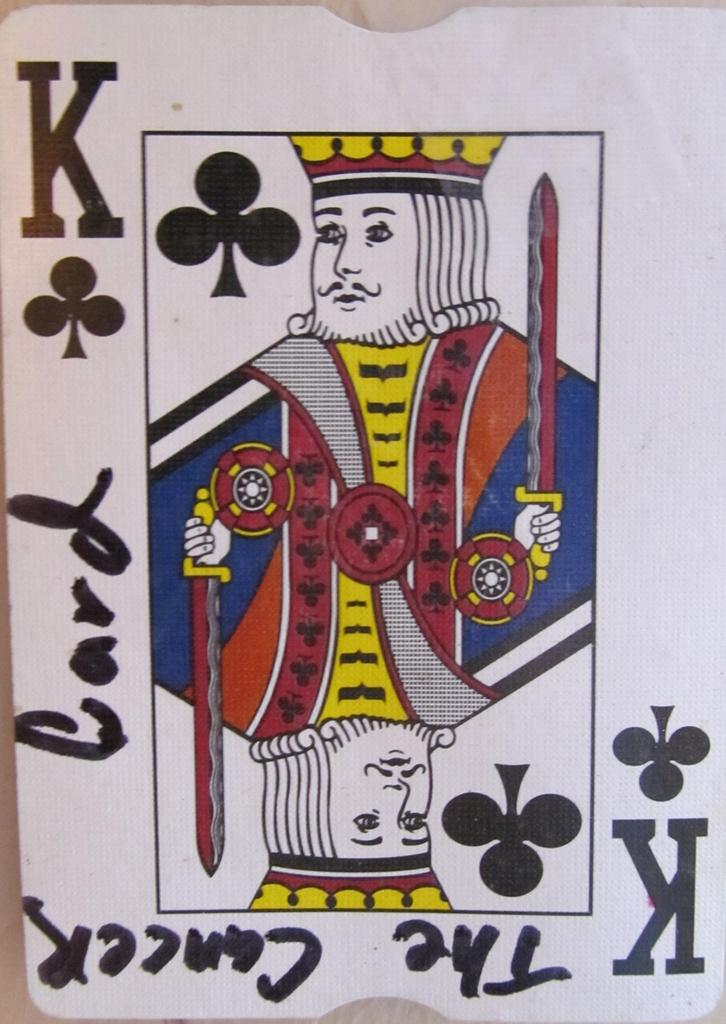<image>
Provide a brief description of the given image. King card from a deck of playing cards with the cancer card wrote on it in black marker 